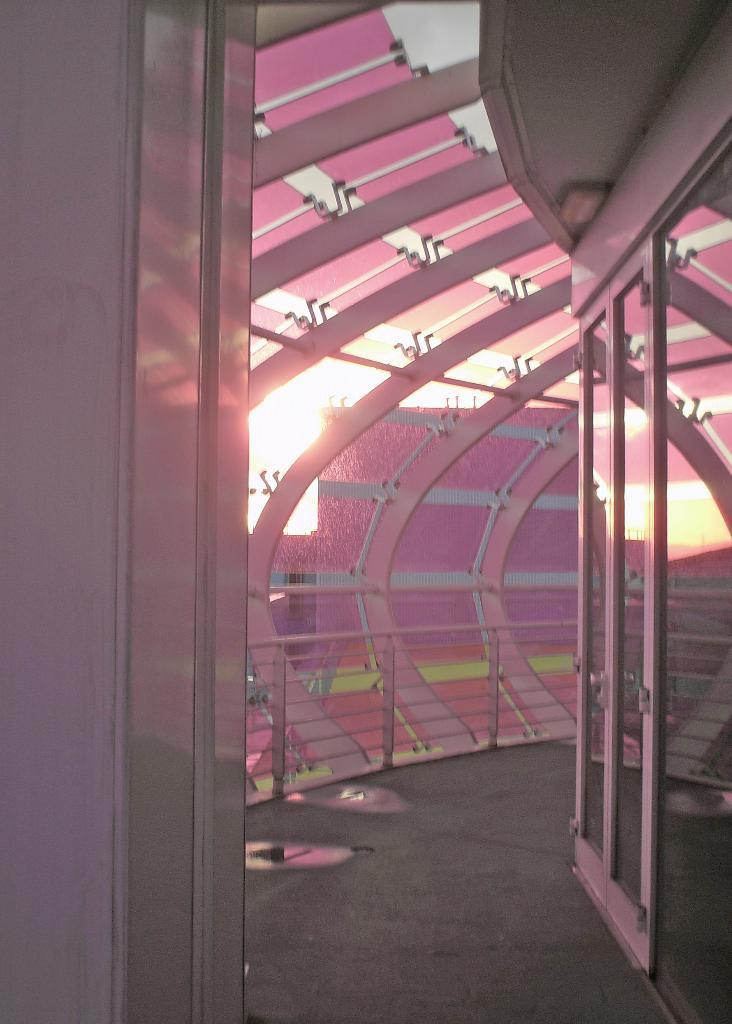What type of structure is depicted in the image? There is an architecture in the image. What specific feature can be seen on the architecture? The architecture includes a glass door and an iron fencing. Can you describe the ceiling in the architecture? The ceiling in the architecture has a design. What can be seen in the background of the image? There is light visible in the background of the image. How many toes are visible on the architecture in the image? There are no toes present in the image, as it features an architecture with a glass door, iron fencing, and a designed ceiling. What emotion is the porter displaying in the image? There is no porter present in the image, so it is not possible to determine their emotions. 